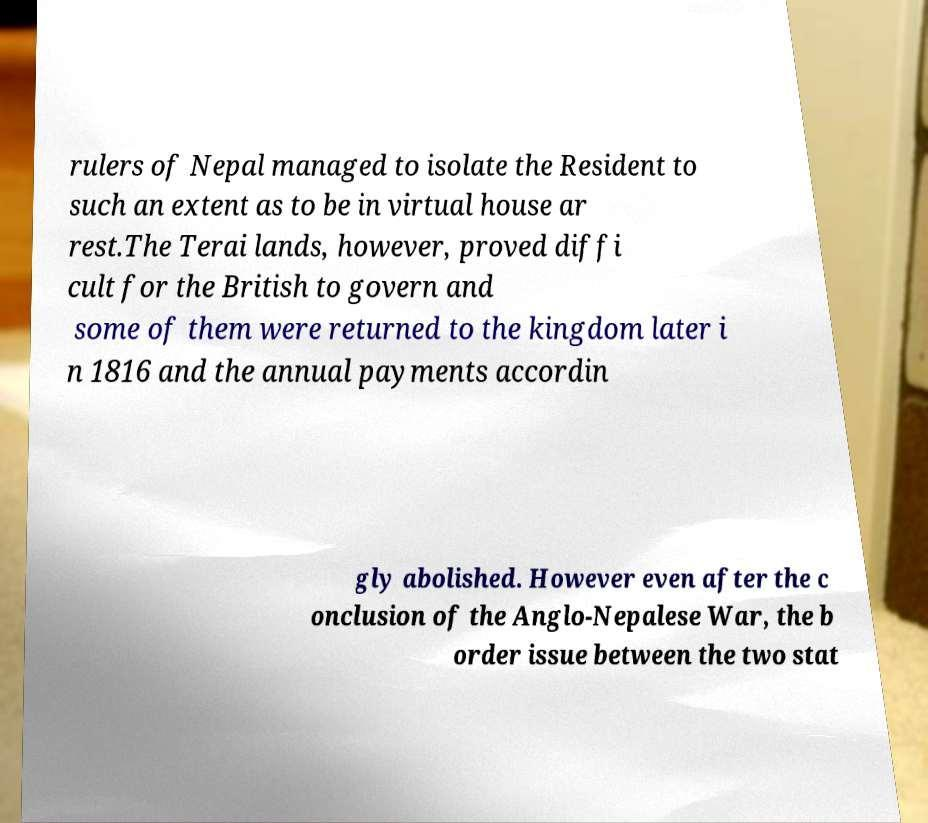Can you read and provide the text displayed in the image?This photo seems to have some interesting text. Can you extract and type it out for me? rulers of Nepal managed to isolate the Resident to such an extent as to be in virtual house ar rest.The Terai lands, however, proved diffi cult for the British to govern and some of them were returned to the kingdom later i n 1816 and the annual payments accordin gly abolished. However even after the c onclusion of the Anglo-Nepalese War, the b order issue between the two stat 